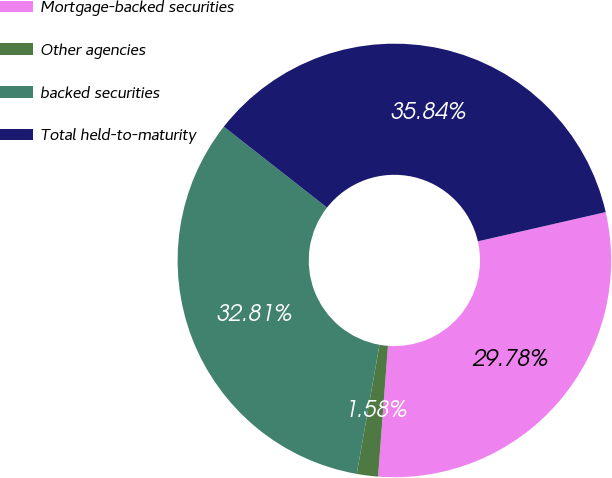Convert chart. <chart><loc_0><loc_0><loc_500><loc_500><pie_chart><fcel>Mortgage-backed securities<fcel>Other agencies<fcel>backed securities<fcel>Total held-to-maturity<nl><fcel>29.78%<fcel>1.58%<fcel>32.81%<fcel>35.84%<nl></chart> 